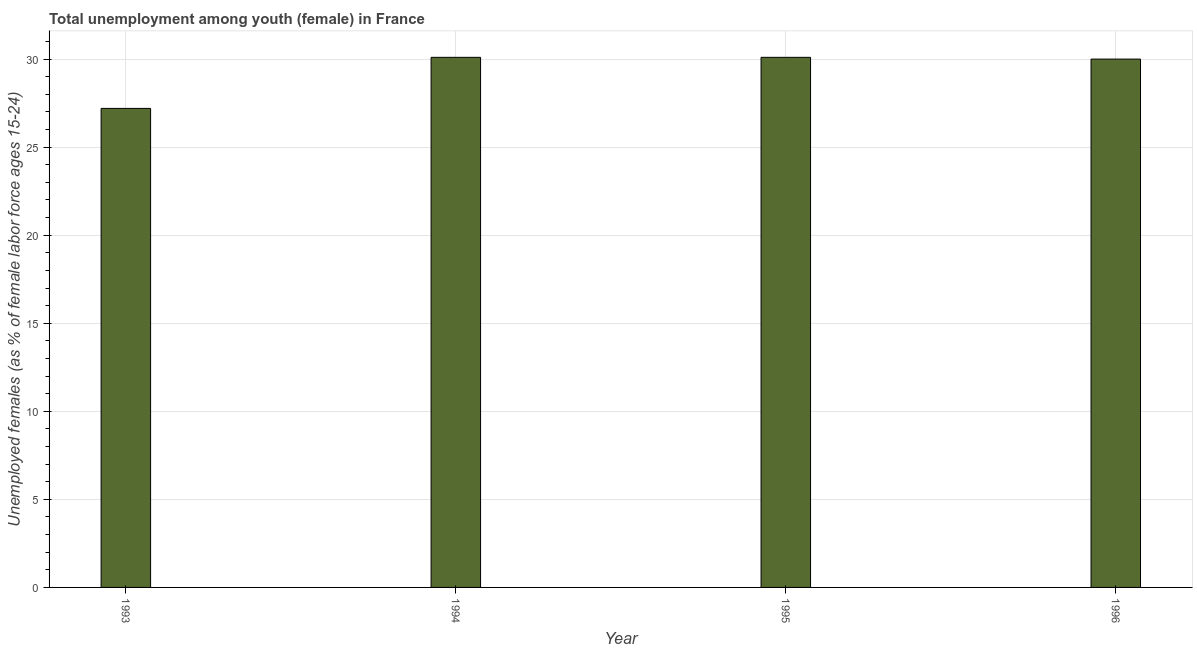What is the title of the graph?
Keep it short and to the point. Total unemployment among youth (female) in France. What is the label or title of the X-axis?
Give a very brief answer. Year. What is the label or title of the Y-axis?
Your answer should be compact. Unemployed females (as % of female labor force ages 15-24). What is the unemployed female youth population in 1994?
Offer a very short reply. 30.1. Across all years, what is the maximum unemployed female youth population?
Make the answer very short. 30.1. Across all years, what is the minimum unemployed female youth population?
Your answer should be very brief. 27.2. In which year was the unemployed female youth population minimum?
Offer a terse response. 1993. What is the sum of the unemployed female youth population?
Offer a terse response. 117.4. What is the difference between the unemployed female youth population in 1993 and 1996?
Make the answer very short. -2.8. What is the average unemployed female youth population per year?
Give a very brief answer. 29.35. What is the median unemployed female youth population?
Offer a terse response. 30.05. What is the ratio of the unemployed female youth population in 1993 to that in 1994?
Your answer should be very brief. 0.9. Is the difference between the unemployed female youth population in 1993 and 1995 greater than the difference between any two years?
Provide a short and direct response. Yes. What is the difference between the highest and the lowest unemployed female youth population?
Your answer should be very brief. 2.9. In how many years, is the unemployed female youth population greater than the average unemployed female youth population taken over all years?
Keep it short and to the point. 3. Are all the bars in the graph horizontal?
Give a very brief answer. No. What is the difference between two consecutive major ticks on the Y-axis?
Offer a terse response. 5. Are the values on the major ticks of Y-axis written in scientific E-notation?
Keep it short and to the point. No. What is the Unemployed females (as % of female labor force ages 15-24) of 1993?
Offer a very short reply. 27.2. What is the Unemployed females (as % of female labor force ages 15-24) in 1994?
Provide a succinct answer. 30.1. What is the Unemployed females (as % of female labor force ages 15-24) in 1995?
Your answer should be very brief. 30.1. What is the difference between the Unemployed females (as % of female labor force ages 15-24) in 1993 and 1995?
Provide a succinct answer. -2.9. What is the difference between the Unemployed females (as % of female labor force ages 15-24) in 1995 and 1996?
Make the answer very short. 0.1. What is the ratio of the Unemployed females (as % of female labor force ages 15-24) in 1993 to that in 1994?
Provide a succinct answer. 0.9. What is the ratio of the Unemployed females (as % of female labor force ages 15-24) in 1993 to that in 1995?
Keep it short and to the point. 0.9. What is the ratio of the Unemployed females (as % of female labor force ages 15-24) in 1993 to that in 1996?
Offer a very short reply. 0.91. What is the ratio of the Unemployed females (as % of female labor force ages 15-24) in 1994 to that in 1996?
Keep it short and to the point. 1. 